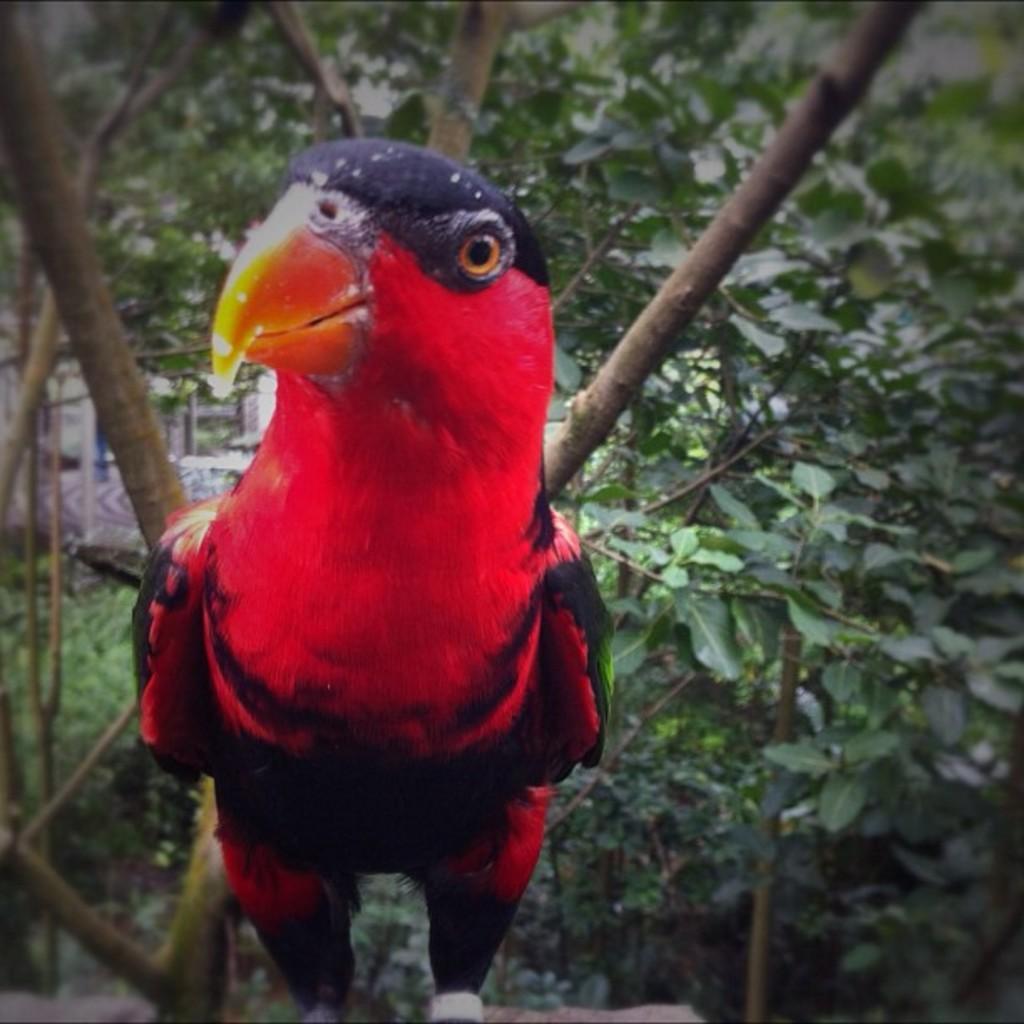Describe this image in one or two sentences. In this image in the center there is one bird, and in the background there are some trees. 